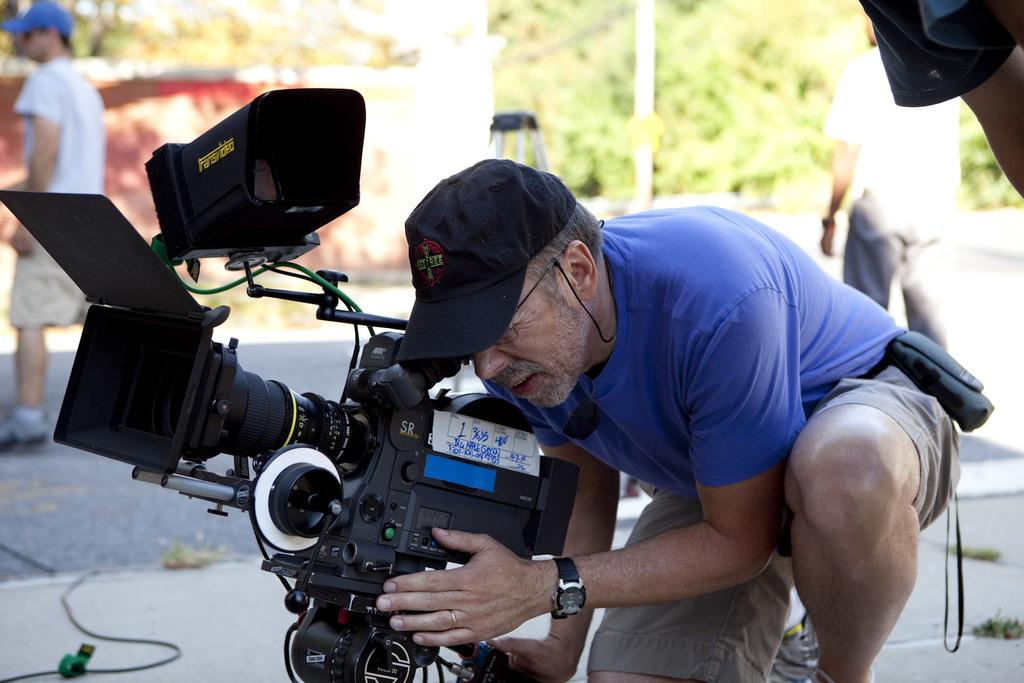Who is the main subject in the image? There is a man in the picture. What is the man doing in the image? The man is looking at the camera and appears focused. What can be seen in the background of the image? There is a camera stand, a guy, and trees in the background of the image. What type of stocking is the man wearing in the image? There is no mention of stockings in the image, so it cannot be determined if the man is wearing any. 